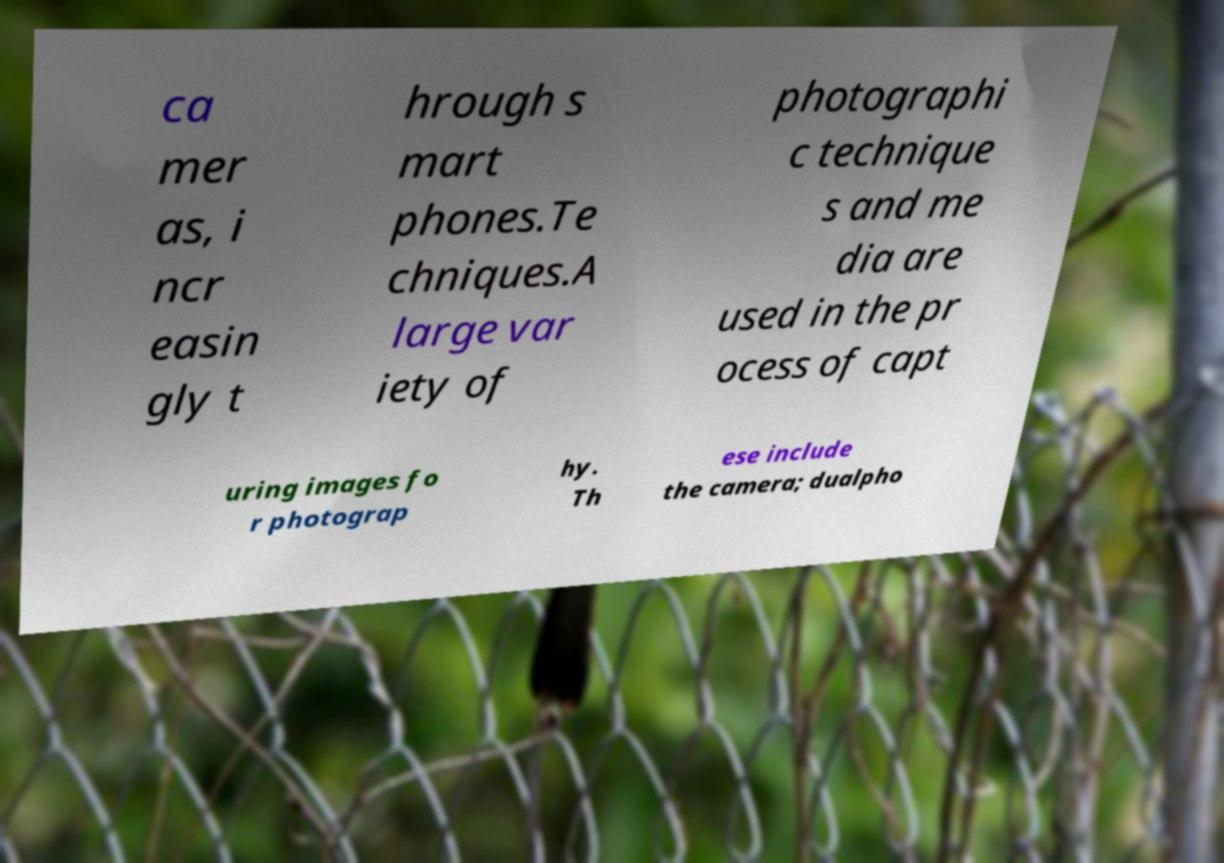Can you read and provide the text displayed in the image?This photo seems to have some interesting text. Can you extract and type it out for me? ca mer as, i ncr easin gly t hrough s mart phones.Te chniques.A large var iety of photographi c technique s and me dia are used in the pr ocess of capt uring images fo r photograp hy. Th ese include the camera; dualpho 